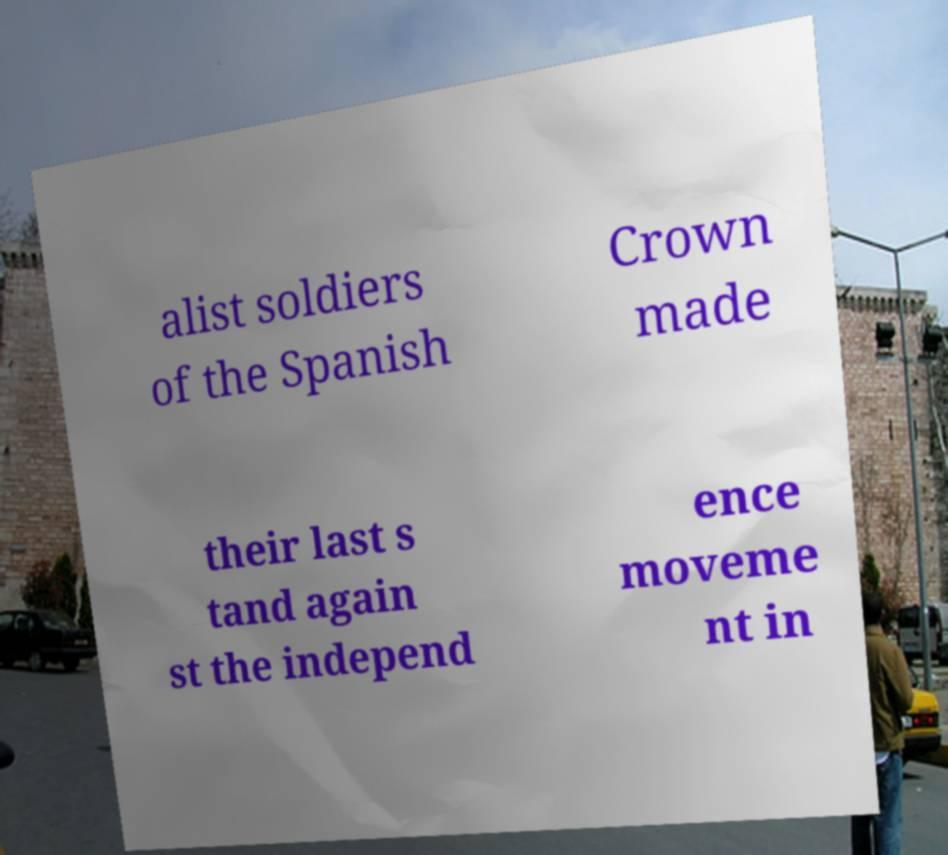There's text embedded in this image that I need extracted. Can you transcribe it verbatim? alist soldiers of the Spanish Crown made their last s tand again st the independ ence moveme nt in 